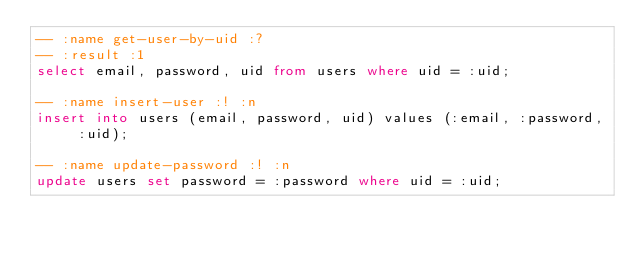Convert code to text. <code><loc_0><loc_0><loc_500><loc_500><_SQL_>-- :name get-user-by-uid :?
-- :result :1
select email, password, uid from users where uid = :uid;

-- :name insert-user :! :n
insert into users (email, password, uid) values (:email, :password, :uid);

-- :name update-password :! :n
update users set password = :password where uid = :uid;
</code> 